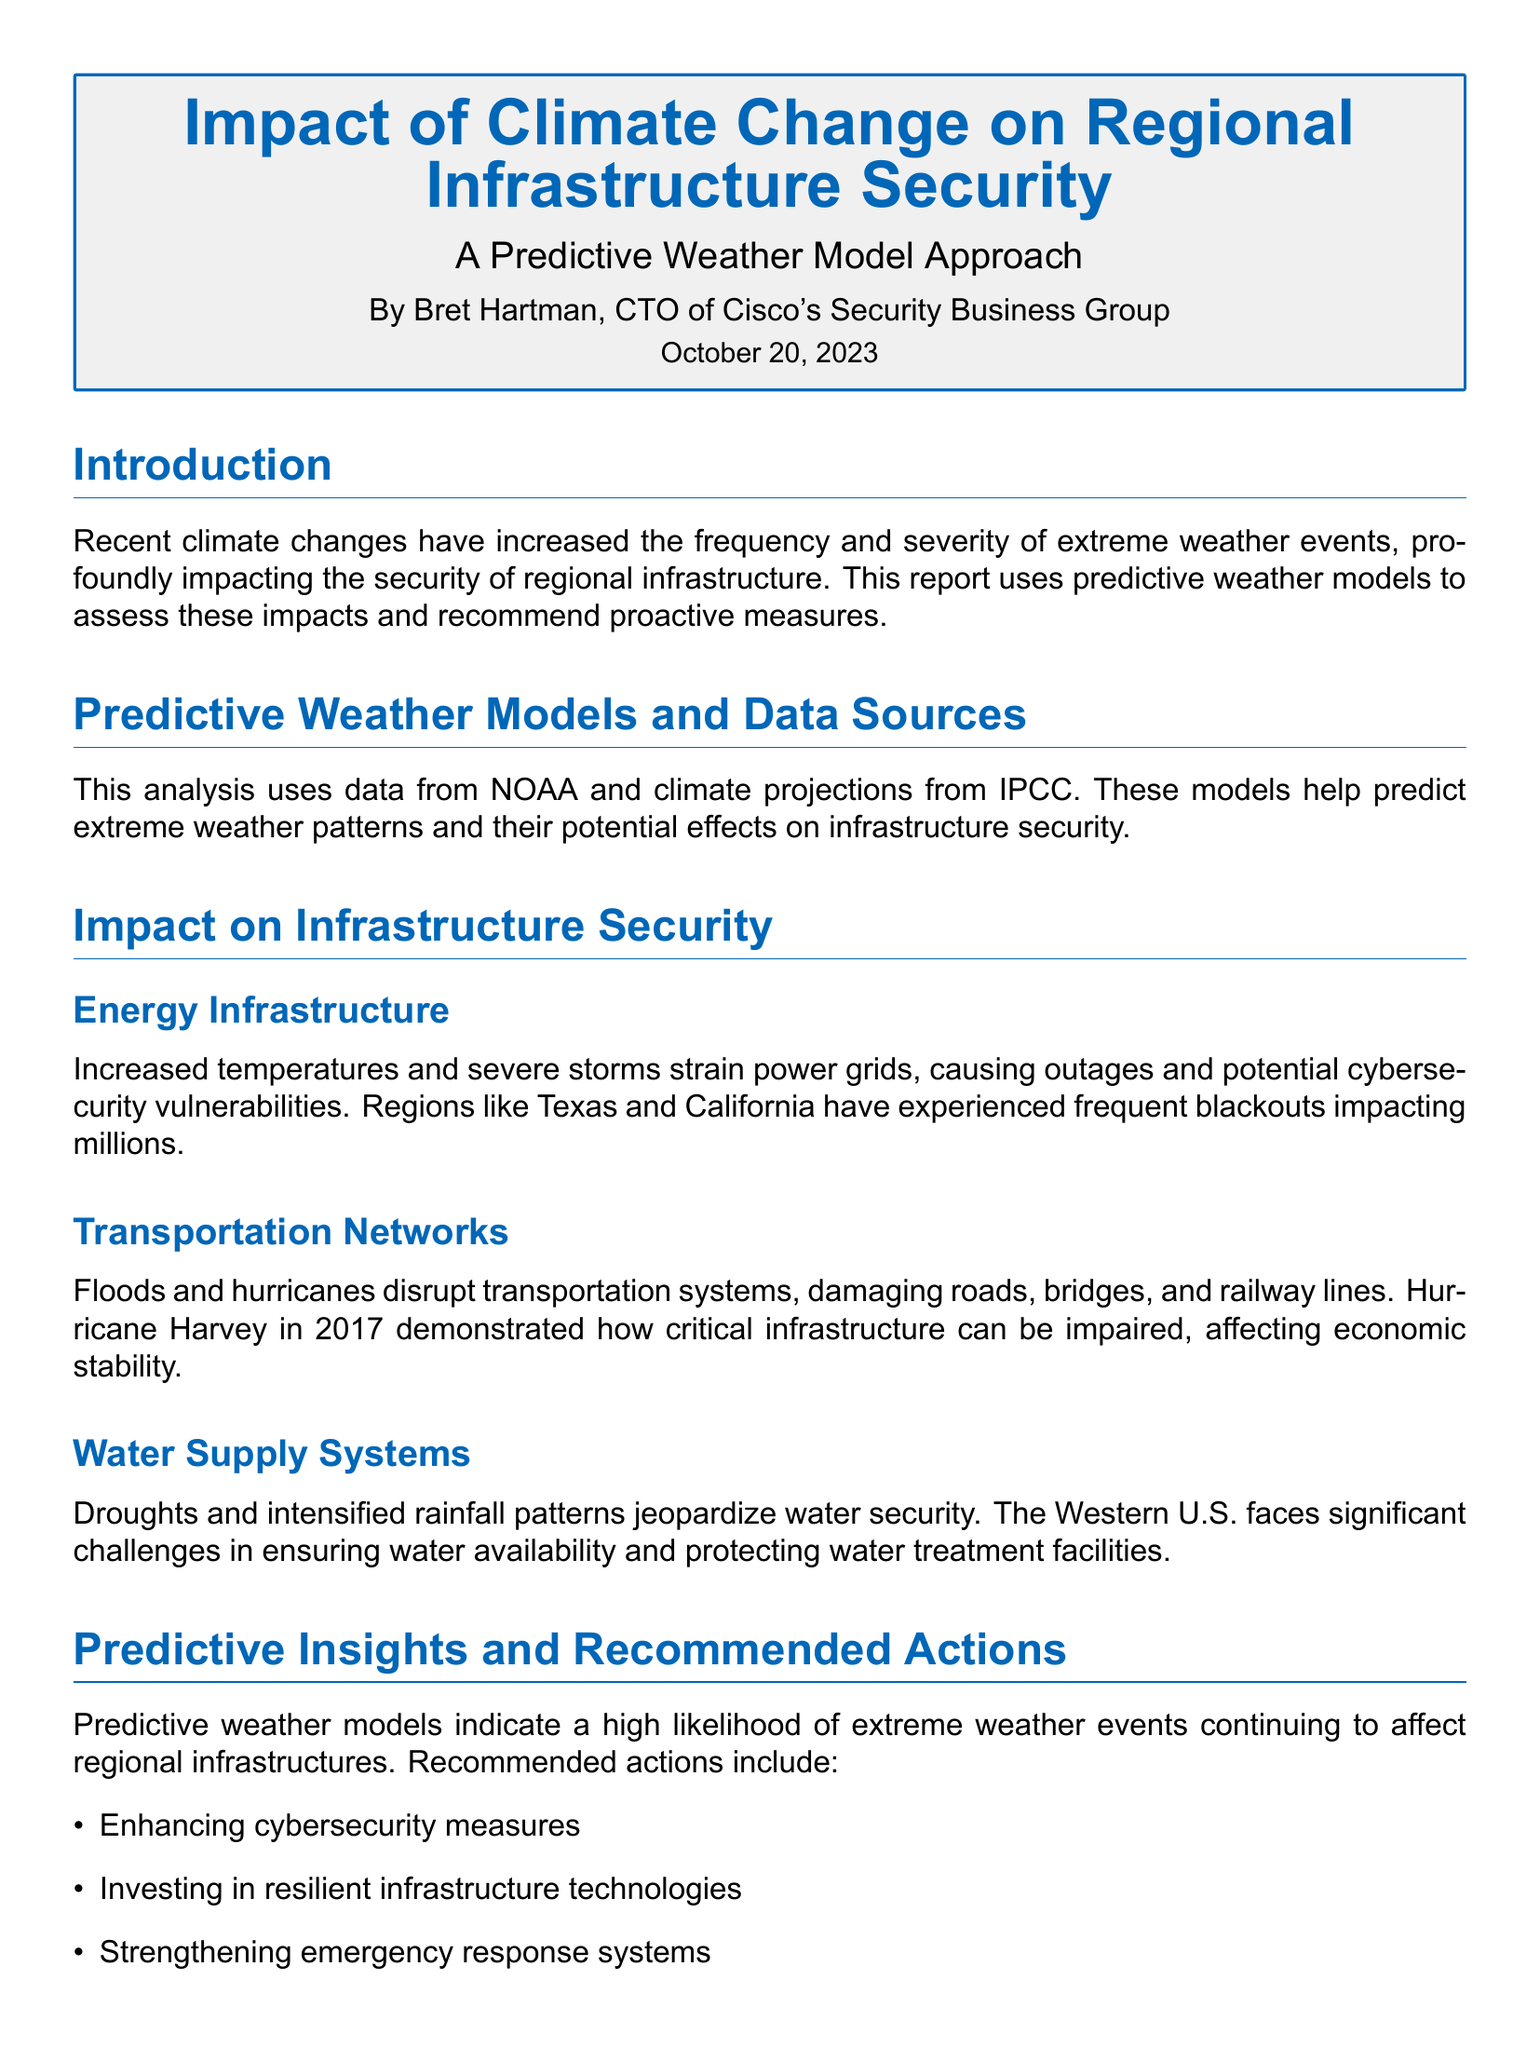What is the title of the report? The title is prominently displayed at the beginning of the document.
Answer: Impact of Climate Change on Regional Infrastructure Security Who is the author of the report? The author is mentioned in the introductory section of the document.
Answer: Bret Hartman What date was the report published? The publication date is included at the top of the document.
Answer: October 20, 2023 Which data sources are used in the analysis? The document lists the sources used for the predictive weather models.
Answer: NOAA and IPCC What event exemplified the impact on transportation networks? The document provides a specific example illustrating disruption in transportation due to extreme weather.
Answer: Hurricane Harvey What is one recommended action for improving infrastructure security? The document includes a list of recommended actions for mitigation.
Answer: Enhancing cybersecurity measures Which region has experienced frequent blackouts due to climate change? The document specifies regions that have been affected by power outages related to climate events.
Answer: Texas and California What type of visualizations are included in the document? The document describes the types of visualizations present.
Answer: Map and Bar Chart 